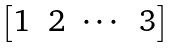<formula> <loc_0><loc_0><loc_500><loc_500>\begin{bmatrix} 1 & 2 & \cdots & 3 \end{bmatrix}</formula> 